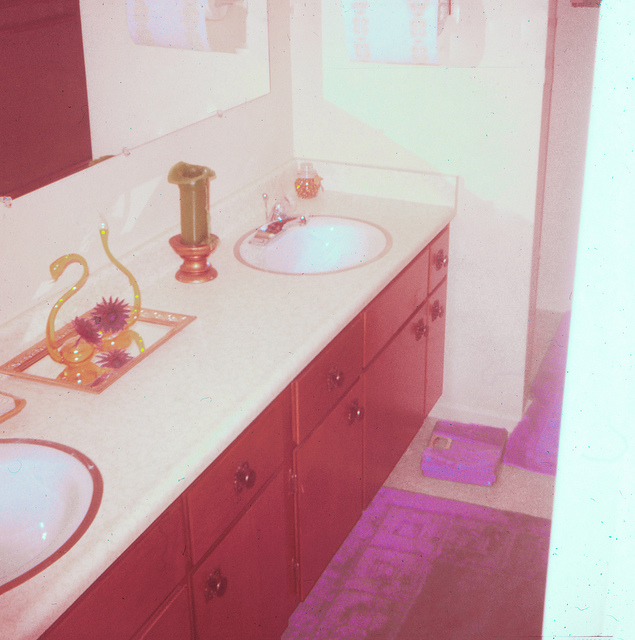<image>What pattern is shown on the mats? I am not sure what pattern is shown on the mats. It could be square or maze-like. What pattern is shown on the mats? I am not sure what pattern is shown on the mats. It can be seen square, maze like, squares with smaller squares inside, or boxes. 